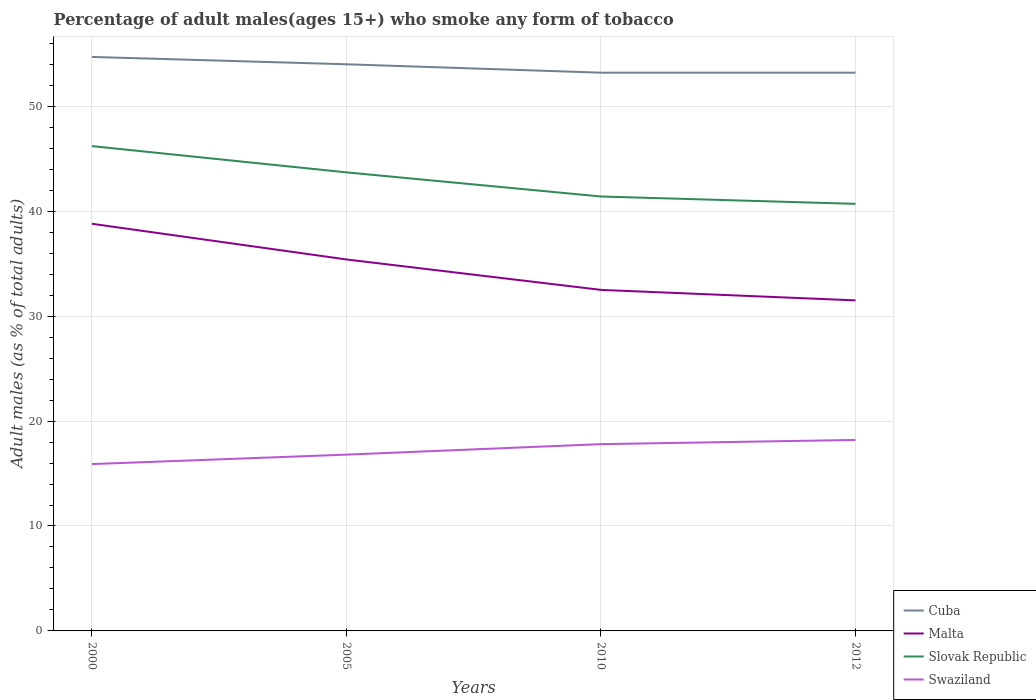Does the line corresponding to Swaziland intersect with the line corresponding to Slovak Republic?
Give a very brief answer. No. Across all years, what is the maximum percentage of adult males who smoke in Swaziland?
Your response must be concise. 15.9. In which year was the percentage of adult males who smoke in Slovak Republic maximum?
Give a very brief answer. 2012. What is the total percentage of adult males who smoke in Malta in the graph?
Your answer should be very brief. 2.9. What is the difference between the highest and the lowest percentage of adult males who smoke in Malta?
Ensure brevity in your answer.  2. Does the graph contain grids?
Provide a short and direct response. Yes. How many legend labels are there?
Provide a short and direct response. 4. What is the title of the graph?
Provide a succinct answer. Percentage of adult males(ages 15+) who smoke any form of tobacco. What is the label or title of the X-axis?
Give a very brief answer. Years. What is the label or title of the Y-axis?
Keep it short and to the point. Adult males (as % of total adults). What is the Adult males (as % of total adults) of Cuba in 2000?
Offer a terse response. 54.7. What is the Adult males (as % of total adults) of Malta in 2000?
Your answer should be compact. 38.8. What is the Adult males (as % of total adults) in Slovak Republic in 2000?
Offer a very short reply. 46.2. What is the Adult males (as % of total adults) of Malta in 2005?
Offer a terse response. 35.4. What is the Adult males (as % of total adults) of Slovak Republic in 2005?
Offer a very short reply. 43.7. What is the Adult males (as % of total adults) in Swaziland in 2005?
Provide a succinct answer. 16.8. What is the Adult males (as % of total adults) of Cuba in 2010?
Ensure brevity in your answer.  53.2. What is the Adult males (as % of total adults) in Malta in 2010?
Provide a short and direct response. 32.5. What is the Adult males (as % of total adults) in Slovak Republic in 2010?
Provide a short and direct response. 41.4. What is the Adult males (as % of total adults) in Cuba in 2012?
Provide a succinct answer. 53.2. What is the Adult males (as % of total adults) of Malta in 2012?
Ensure brevity in your answer.  31.5. What is the Adult males (as % of total adults) of Slovak Republic in 2012?
Your answer should be very brief. 40.7. Across all years, what is the maximum Adult males (as % of total adults) of Cuba?
Your answer should be compact. 54.7. Across all years, what is the maximum Adult males (as % of total adults) of Malta?
Make the answer very short. 38.8. Across all years, what is the maximum Adult males (as % of total adults) of Slovak Republic?
Your answer should be compact. 46.2. Across all years, what is the minimum Adult males (as % of total adults) of Cuba?
Ensure brevity in your answer.  53.2. Across all years, what is the minimum Adult males (as % of total adults) of Malta?
Your answer should be compact. 31.5. Across all years, what is the minimum Adult males (as % of total adults) in Slovak Republic?
Keep it short and to the point. 40.7. What is the total Adult males (as % of total adults) of Cuba in the graph?
Your answer should be very brief. 215.1. What is the total Adult males (as % of total adults) of Malta in the graph?
Offer a terse response. 138.2. What is the total Adult males (as % of total adults) in Slovak Republic in the graph?
Give a very brief answer. 172. What is the total Adult males (as % of total adults) in Swaziland in the graph?
Keep it short and to the point. 68.7. What is the difference between the Adult males (as % of total adults) in Slovak Republic in 2000 and that in 2005?
Keep it short and to the point. 2.5. What is the difference between the Adult males (as % of total adults) in Cuba in 2000 and that in 2010?
Give a very brief answer. 1.5. What is the difference between the Adult males (as % of total adults) of Malta in 2000 and that in 2010?
Provide a succinct answer. 6.3. What is the difference between the Adult males (as % of total adults) of Cuba in 2000 and that in 2012?
Offer a very short reply. 1.5. What is the difference between the Adult males (as % of total adults) of Cuba in 2005 and that in 2010?
Offer a terse response. 0.8. What is the difference between the Adult males (as % of total adults) in Malta in 2005 and that in 2010?
Provide a short and direct response. 2.9. What is the difference between the Adult males (as % of total adults) of Swaziland in 2005 and that in 2010?
Make the answer very short. -1. What is the difference between the Adult males (as % of total adults) in Malta in 2005 and that in 2012?
Give a very brief answer. 3.9. What is the difference between the Adult males (as % of total adults) in Slovak Republic in 2005 and that in 2012?
Provide a short and direct response. 3. What is the difference between the Adult males (as % of total adults) of Swaziland in 2010 and that in 2012?
Your response must be concise. -0.4. What is the difference between the Adult males (as % of total adults) of Cuba in 2000 and the Adult males (as % of total adults) of Malta in 2005?
Your answer should be compact. 19.3. What is the difference between the Adult males (as % of total adults) in Cuba in 2000 and the Adult males (as % of total adults) in Swaziland in 2005?
Ensure brevity in your answer.  37.9. What is the difference between the Adult males (as % of total adults) of Malta in 2000 and the Adult males (as % of total adults) of Slovak Republic in 2005?
Provide a succinct answer. -4.9. What is the difference between the Adult males (as % of total adults) of Malta in 2000 and the Adult males (as % of total adults) of Swaziland in 2005?
Give a very brief answer. 22. What is the difference between the Adult males (as % of total adults) in Slovak Republic in 2000 and the Adult males (as % of total adults) in Swaziland in 2005?
Your answer should be compact. 29.4. What is the difference between the Adult males (as % of total adults) of Cuba in 2000 and the Adult males (as % of total adults) of Slovak Republic in 2010?
Offer a very short reply. 13.3. What is the difference between the Adult males (as % of total adults) in Cuba in 2000 and the Adult males (as % of total adults) in Swaziland in 2010?
Provide a short and direct response. 36.9. What is the difference between the Adult males (as % of total adults) of Malta in 2000 and the Adult males (as % of total adults) of Swaziland in 2010?
Offer a terse response. 21. What is the difference between the Adult males (as % of total adults) in Slovak Republic in 2000 and the Adult males (as % of total adults) in Swaziland in 2010?
Give a very brief answer. 28.4. What is the difference between the Adult males (as % of total adults) in Cuba in 2000 and the Adult males (as % of total adults) in Malta in 2012?
Offer a terse response. 23.2. What is the difference between the Adult males (as % of total adults) in Cuba in 2000 and the Adult males (as % of total adults) in Slovak Republic in 2012?
Your response must be concise. 14. What is the difference between the Adult males (as % of total adults) of Cuba in 2000 and the Adult males (as % of total adults) of Swaziland in 2012?
Give a very brief answer. 36.5. What is the difference between the Adult males (as % of total adults) of Malta in 2000 and the Adult males (as % of total adults) of Slovak Republic in 2012?
Give a very brief answer. -1.9. What is the difference between the Adult males (as % of total adults) of Malta in 2000 and the Adult males (as % of total adults) of Swaziland in 2012?
Give a very brief answer. 20.6. What is the difference between the Adult males (as % of total adults) of Cuba in 2005 and the Adult males (as % of total adults) of Malta in 2010?
Provide a succinct answer. 21.5. What is the difference between the Adult males (as % of total adults) in Cuba in 2005 and the Adult males (as % of total adults) in Swaziland in 2010?
Give a very brief answer. 36.2. What is the difference between the Adult males (as % of total adults) of Malta in 2005 and the Adult males (as % of total adults) of Slovak Republic in 2010?
Your answer should be very brief. -6. What is the difference between the Adult males (as % of total adults) in Slovak Republic in 2005 and the Adult males (as % of total adults) in Swaziland in 2010?
Provide a short and direct response. 25.9. What is the difference between the Adult males (as % of total adults) of Cuba in 2005 and the Adult males (as % of total adults) of Malta in 2012?
Provide a succinct answer. 22.5. What is the difference between the Adult males (as % of total adults) in Cuba in 2005 and the Adult males (as % of total adults) in Swaziland in 2012?
Ensure brevity in your answer.  35.8. What is the difference between the Adult males (as % of total adults) of Malta in 2005 and the Adult males (as % of total adults) of Swaziland in 2012?
Your answer should be very brief. 17.2. What is the difference between the Adult males (as % of total adults) in Slovak Republic in 2005 and the Adult males (as % of total adults) in Swaziland in 2012?
Your answer should be very brief. 25.5. What is the difference between the Adult males (as % of total adults) in Cuba in 2010 and the Adult males (as % of total adults) in Malta in 2012?
Ensure brevity in your answer.  21.7. What is the difference between the Adult males (as % of total adults) of Cuba in 2010 and the Adult males (as % of total adults) of Slovak Republic in 2012?
Keep it short and to the point. 12.5. What is the difference between the Adult males (as % of total adults) of Cuba in 2010 and the Adult males (as % of total adults) of Swaziland in 2012?
Provide a short and direct response. 35. What is the difference between the Adult males (as % of total adults) of Malta in 2010 and the Adult males (as % of total adults) of Slovak Republic in 2012?
Provide a short and direct response. -8.2. What is the difference between the Adult males (as % of total adults) in Malta in 2010 and the Adult males (as % of total adults) in Swaziland in 2012?
Offer a terse response. 14.3. What is the difference between the Adult males (as % of total adults) in Slovak Republic in 2010 and the Adult males (as % of total adults) in Swaziland in 2012?
Your answer should be compact. 23.2. What is the average Adult males (as % of total adults) in Cuba per year?
Your response must be concise. 53.77. What is the average Adult males (as % of total adults) of Malta per year?
Make the answer very short. 34.55. What is the average Adult males (as % of total adults) in Slovak Republic per year?
Ensure brevity in your answer.  43. What is the average Adult males (as % of total adults) of Swaziland per year?
Give a very brief answer. 17.18. In the year 2000, what is the difference between the Adult males (as % of total adults) of Cuba and Adult males (as % of total adults) of Malta?
Provide a short and direct response. 15.9. In the year 2000, what is the difference between the Adult males (as % of total adults) of Cuba and Adult males (as % of total adults) of Swaziland?
Your response must be concise. 38.8. In the year 2000, what is the difference between the Adult males (as % of total adults) of Malta and Adult males (as % of total adults) of Swaziland?
Offer a terse response. 22.9. In the year 2000, what is the difference between the Adult males (as % of total adults) in Slovak Republic and Adult males (as % of total adults) in Swaziland?
Your answer should be compact. 30.3. In the year 2005, what is the difference between the Adult males (as % of total adults) in Cuba and Adult males (as % of total adults) in Malta?
Ensure brevity in your answer.  18.6. In the year 2005, what is the difference between the Adult males (as % of total adults) of Cuba and Adult males (as % of total adults) of Slovak Republic?
Offer a very short reply. 10.3. In the year 2005, what is the difference between the Adult males (as % of total adults) of Cuba and Adult males (as % of total adults) of Swaziland?
Provide a succinct answer. 37.2. In the year 2005, what is the difference between the Adult males (as % of total adults) of Malta and Adult males (as % of total adults) of Slovak Republic?
Your response must be concise. -8.3. In the year 2005, what is the difference between the Adult males (as % of total adults) in Malta and Adult males (as % of total adults) in Swaziland?
Ensure brevity in your answer.  18.6. In the year 2005, what is the difference between the Adult males (as % of total adults) of Slovak Republic and Adult males (as % of total adults) of Swaziland?
Keep it short and to the point. 26.9. In the year 2010, what is the difference between the Adult males (as % of total adults) in Cuba and Adult males (as % of total adults) in Malta?
Your answer should be very brief. 20.7. In the year 2010, what is the difference between the Adult males (as % of total adults) in Cuba and Adult males (as % of total adults) in Slovak Republic?
Provide a succinct answer. 11.8. In the year 2010, what is the difference between the Adult males (as % of total adults) in Cuba and Adult males (as % of total adults) in Swaziland?
Provide a short and direct response. 35.4. In the year 2010, what is the difference between the Adult males (as % of total adults) in Malta and Adult males (as % of total adults) in Slovak Republic?
Your answer should be very brief. -8.9. In the year 2010, what is the difference between the Adult males (as % of total adults) of Slovak Republic and Adult males (as % of total adults) of Swaziland?
Offer a terse response. 23.6. In the year 2012, what is the difference between the Adult males (as % of total adults) of Cuba and Adult males (as % of total adults) of Malta?
Offer a very short reply. 21.7. In the year 2012, what is the difference between the Adult males (as % of total adults) in Cuba and Adult males (as % of total adults) in Slovak Republic?
Your answer should be very brief. 12.5. In the year 2012, what is the difference between the Adult males (as % of total adults) of Malta and Adult males (as % of total adults) of Swaziland?
Make the answer very short. 13.3. In the year 2012, what is the difference between the Adult males (as % of total adults) in Slovak Republic and Adult males (as % of total adults) in Swaziland?
Your answer should be compact. 22.5. What is the ratio of the Adult males (as % of total adults) in Malta in 2000 to that in 2005?
Make the answer very short. 1.1. What is the ratio of the Adult males (as % of total adults) in Slovak Republic in 2000 to that in 2005?
Your answer should be compact. 1.06. What is the ratio of the Adult males (as % of total adults) in Swaziland in 2000 to that in 2005?
Make the answer very short. 0.95. What is the ratio of the Adult males (as % of total adults) in Cuba in 2000 to that in 2010?
Provide a succinct answer. 1.03. What is the ratio of the Adult males (as % of total adults) of Malta in 2000 to that in 2010?
Your response must be concise. 1.19. What is the ratio of the Adult males (as % of total adults) in Slovak Republic in 2000 to that in 2010?
Your response must be concise. 1.12. What is the ratio of the Adult males (as % of total adults) in Swaziland in 2000 to that in 2010?
Provide a succinct answer. 0.89. What is the ratio of the Adult males (as % of total adults) in Cuba in 2000 to that in 2012?
Your answer should be very brief. 1.03. What is the ratio of the Adult males (as % of total adults) of Malta in 2000 to that in 2012?
Ensure brevity in your answer.  1.23. What is the ratio of the Adult males (as % of total adults) of Slovak Republic in 2000 to that in 2012?
Your answer should be compact. 1.14. What is the ratio of the Adult males (as % of total adults) in Swaziland in 2000 to that in 2012?
Ensure brevity in your answer.  0.87. What is the ratio of the Adult males (as % of total adults) of Cuba in 2005 to that in 2010?
Give a very brief answer. 1.01. What is the ratio of the Adult males (as % of total adults) of Malta in 2005 to that in 2010?
Provide a succinct answer. 1.09. What is the ratio of the Adult males (as % of total adults) of Slovak Republic in 2005 to that in 2010?
Keep it short and to the point. 1.06. What is the ratio of the Adult males (as % of total adults) of Swaziland in 2005 to that in 2010?
Provide a succinct answer. 0.94. What is the ratio of the Adult males (as % of total adults) in Malta in 2005 to that in 2012?
Make the answer very short. 1.12. What is the ratio of the Adult males (as % of total adults) in Slovak Republic in 2005 to that in 2012?
Keep it short and to the point. 1.07. What is the ratio of the Adult males (as % of total adults) of Swaziland in 2005 to that in 2012?
Offer a terse response. 0.92. What is the ratio of the Adult males (as % of total adults) of Malta in 2010 to that in 2012?
Your response must be concise. 1.03. What is the ratio of the Adult males (as % of total adults) in Slovak Republic in 2010 to that in 2012?
Your answer should be very brief. 1.02. What is the difference between the highest and the second highest Adult males (as % of total adults) in Malta?
Your response must be concise. 3.4. What is the difference between the highest and the second highest Adult males (as % of total adults) in Swaziland?
Offer a terse response. 0.4. 